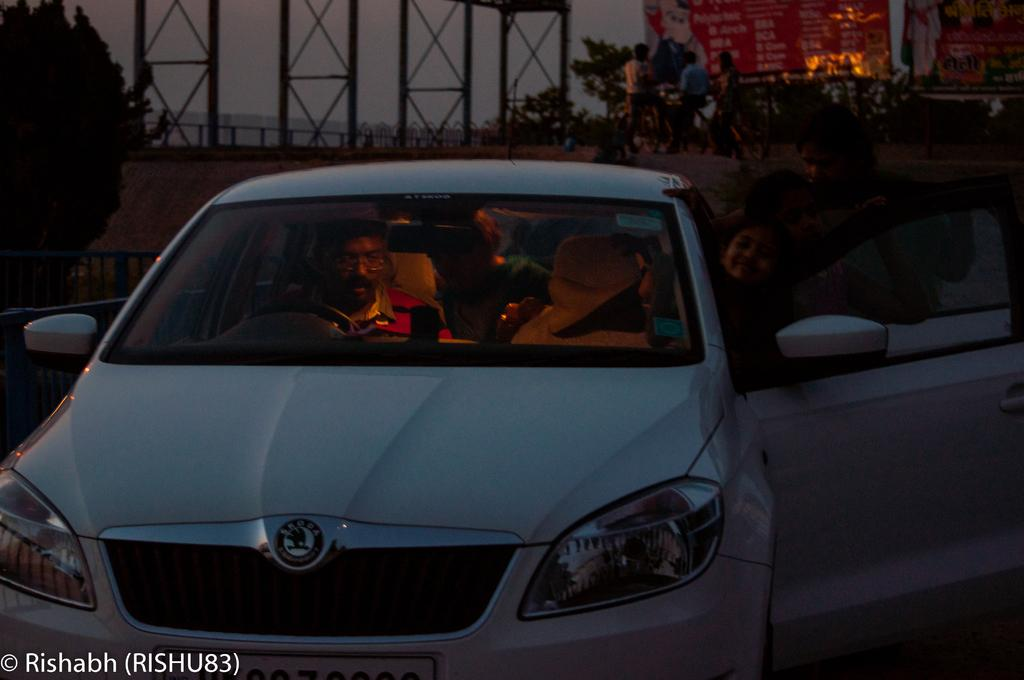What is the main subject of the image? There is a car in the image. Who or what can be seen inside the car? There are people inside the car. What else is visible in the image besides the car and its occupants? There are people and plants visible in the background of the image. What type of cannon is being fired in the image? There is no cannon present in the image. What kind of apparel are the people wearing in the image? The provided facts do not mention the apparel of the people in the image. 